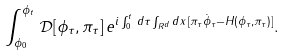Convert formula to latex. <formula><loc_0><loc_0><loc_500><loc_500>\int _ { \phi _ { 0 } } ^ { \phi _ { t } } \, \mathcal { D } [ \phi _ { \tau } , \pi _ { \tau } ] \, e ^ { i \int _ { 0 } ^ { t } \, d \tau \int _ { R ^ { d } } d x \, [ \pi _ { \tau } \dot { \phi } _ { \tau } - H ( \phi _ { \tau } , \pi _ { \tau } ) ] } .</formula> 